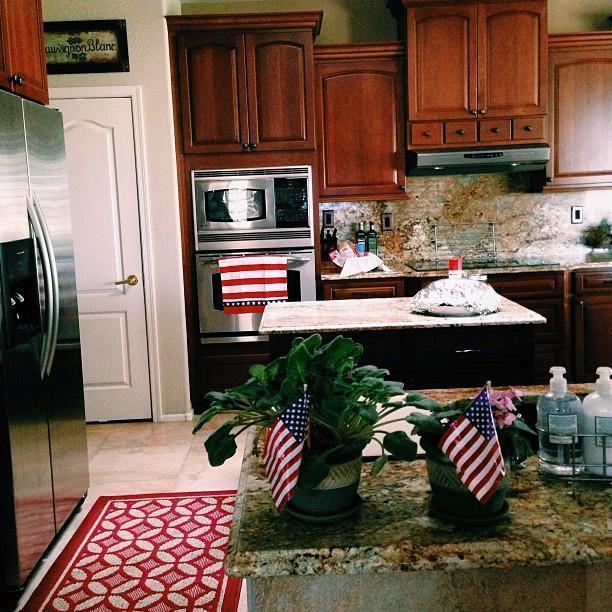How many flags are there?
Give a very brief answer. 2. How many rugs are there?
Give a very brief answer. 1. How many bottles can be seen?
Give a very brief answer. 2. How many potted plants are there?
Give a very brief answer. 2. How many dining tables are there?
Give a very brief answer. 2. 